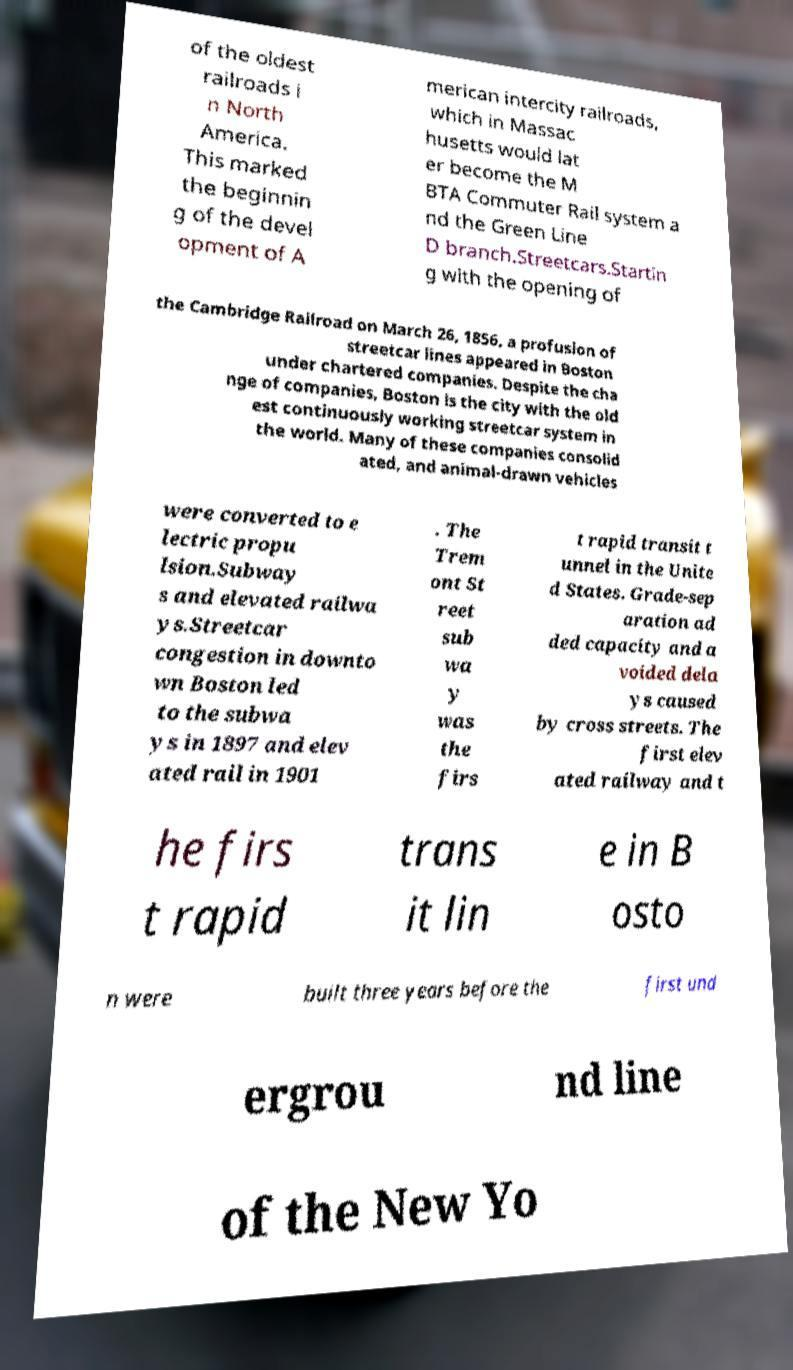Please read and relay the text visible in this image. What does it say? of the oldest railroads i n North America. This marked the beginnin g of the devel opment of A merican intercity railroads, which in Massac husetts would lat er become the M BTA Commuter Rail system a nd the Green Line D branch.Streetcars.Startin g with the opening of the Cambridge Railroad on March 26, 1856, a profusion of streetcar lines appeared in Boston under chartered companies. Despite the cha nge of companies, Boston is the city with the old est continuously working streetcar system in the world. Many of these companies consolid ated, and animal-drawn vehicles were converted to e lectric propu lsion.Subway s and elevated railwa ys.Streetcar congestion in downto wn Boston led to the subwa ys in 1897 and elev ated rail in 1901 . The Trem ont St reet sub wa y was the firs t rapid transit t unnel in the Unite d States. Grade-sep aration ad ded capacity and a voided dela ys caused by cross streets. The first elev ated railway and t he firs t rapid trans it lin e in B osto n were built three years before the first und ergrou nd line of the New Yo 